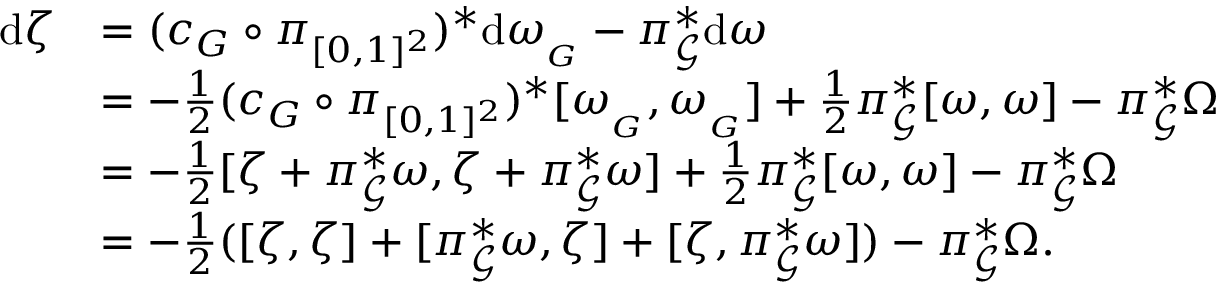<formula> <loc_0><loc_0><loc_500><loc_500>\begin{array} { r l } { d \zeta } & { = ( c _ { G } \circ \pi _ { [ 0 , 1 ] ^ { 2 } } ) ^ { * } d \omega _ { _ { G } } - \pi _ { \ m a t h s c r { G } } ^ { * } d \omega } \\ & { = - \frac { 1 } { 2 } ( c _ { G } \circ \pi _ { [ 0 , 1 ] ^ { 2 } } ) ^ { * } [ \omega _ { _ { G } } , \omega _ { _ { G } } ] + \frac { 1 } { 2 } \pi _ { \ m a t h s c r { G } } ^ { * } [ \omega , \omega ] - \pi _ { \ m a t h s c r { G } } ^ { * } \Omega } \\ & { = - \frac { 1 } { 2 } [ \zeta + \pi _ { \ m a t h s c r { G } } ^ { * } \omega , \zeta + \pi _ { \ m a t h s c r { G } } ^ { * } \omega ] + \frac { 1 } { 2 } \pi _ { \ m a t h s c r { G } } ^ { * } [ \omega , \omega ] - \pi _ { \ m a t h s c r { G } } ^ { * } \Omega } \\ & { = - \frac { 1 } { 2 } ( [ \zeta , \zeta ] + [ \pi _ { \ m a t h s c r { G } } ^ { * } \omega , \zeta ] + [ \zeta , \pi _ { \ m a t h s c r { G } } ^ { * } \omega ] ) - \pi _ { \ m a t h s c r { G } } ^ { * } \Omega . } \end{array}</formula> 